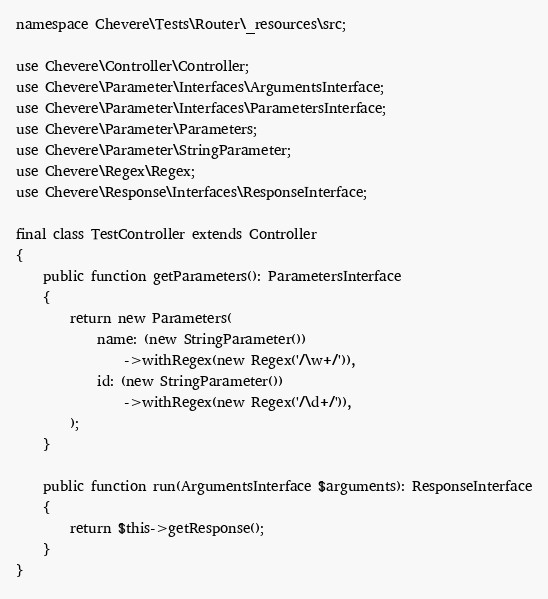<code> <loc_0><loc_0><loc_500><loc_500><_PHP_>
namespace Chevere\Tests\Router\_resources\src;

use Chevere\Controller\Controller;
use Chevere\Parameter\Interfaces\ArgumentsInterface;
use Chevere\Parameter\Interfaces\ParametersInterface;
use Chevere\Parameter\Parameters;
use Chevere\Parameter\StringParameter;
use Chevere\Regex\Regex;
use Chevere\Response\Interfaces\ResponseInterface;

final class TestController extends Controller
{
    public function getParameters(): ParametersInterface
    {
        return new Parameters(
            name: (new StringParameter())
                ->withRegex(new Regex('/\w+/')),
            id: (new StringParameter())
                ->withRegex(new Regex('/\d+/')),
        );
    }

    public function run(ArgumentsInterface $arguments): ResponseInterface
    {
        return $this->getResponse();
    }
}
</code> 